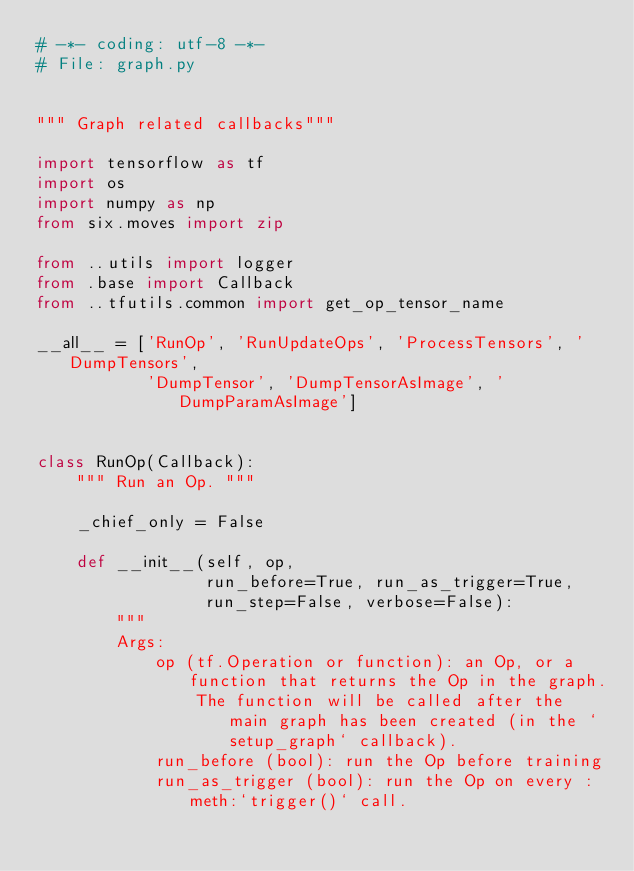Convert code to text. <code><loc_0><loc_0><loc_500><loc_500><_Python_># -*- coding: utf-8 -*-
# File: graph.py


""" Graph related callbacks"""

import tensorflow as tf
import os
import numpy as np
from six.moves import zip

from ..utils import logger
from .base import Callback
from ..tfutils.common import get_op_tensor_name

__all__ = ['RunOp', 'RunUpdateOps', 'ProcessTensors', 'DumpTensors',
           'DumpTensor', 'DumpTensorAsImage', 'DumpParamAsImage']


class RunOp(Callback):
    """ Run an Op. """

    _chief_only = False

    def __init__(self, op,
                 run_before=True, run_as_trigger=True,
                 run_step=False, verbose=False):
        """
        Args:
            op (tf.Operation or function): an Op, or a function that returns the Op in the graph.
                The function will be called after the main graph has been created (in the `setup_graph` callback).
            run_before (bool): run the Op before training
            run_as_trigger (bool): run the Op on every :meth:`trigger()` call.</code> 